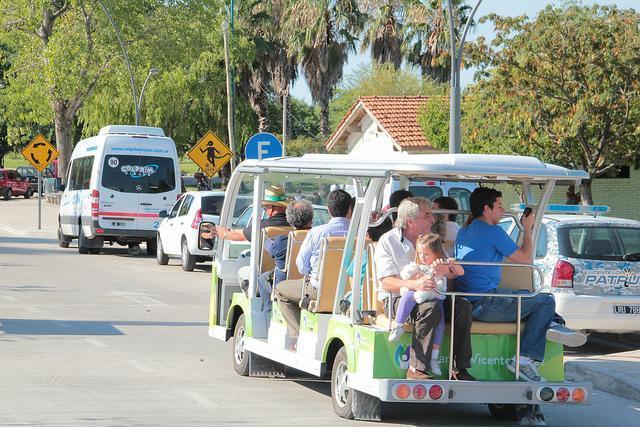How many doors are on this vehicle?
Give a very brief answer. 0. How many people can be seen?
Give a very brief answer. 4. How many cars are in the picture?
Give a very brief answer. 2. How many birds are on the bench?
Give a very brief answer. 0. 